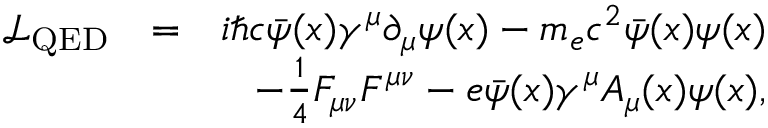Convert formula to latex. <formula><loc_0><loc_0><loc_500><loc_500>\begin{array} { r } { \begin{array} { r l r } { \mathcal { L } _ { Q E D } } & { = } & { i \hbar { c } \bar { \psi } ( x ) \gamma ^ { \mu } \partial _ { \mu } \psi ( x ) - m _ { e } c ^ { 2 } \bar { \psi } ( x ) \psi ( x ) } \\ & { - \frac { 1 } { 4 } F _ { \mu \nu } F ^ { \mu \nu } - e \bar { \psi } ( x ) \gamma ^ { \mu } A _ { \mu } ( x ) \psi ( x ) , } \end{array} } \end{array}</formula> 